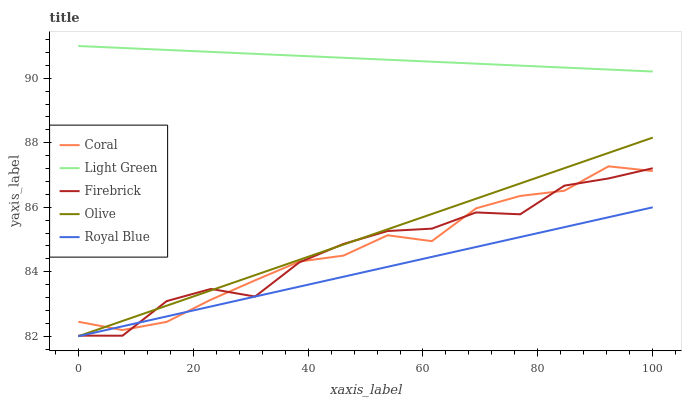Does Royal Blue have the minimum area under the curve?
Answer yes or no. Yes. Does Light Green have the maximum area under the curve?
Answer yes or no. Yes. Does Coral have the minimum area under the curve?
Answer yes or no. No. Does Coral have the maximum area under the curve?
Answer yes or no. No. Is Light Green the smoothest?
Answer yes or no. Yes. Is Firebrick the roughest?
Answer yes or no. Yes. Is Royal Blue the smoothest?
Answer yes or no. No. Is Royal Blue the roughest?
Answer yes or no. No. Does Olive have the lowest value?
Answer yes or no. Yes. Does Coral have the lowest value?
Answer yes or no. No. Does Light Green have the highest value?
Answer yes or no. Yes. Does Coral have the highest value?
Answer yes or no. No. Is Coral less than Light Green?
Answer yes or no. Yes. Is Light Green greater than Coral?
Answer yes or no. Yes. Does Firebrick intersect Coral?
Answer yes or no. Yes. Is Firebrick less than Coral?
Answer yes or no. No. Is Firebrick greater than Coral?
Answer yes or no. No. Does Coral intersect Light Green?
Answer yes or no. No. 